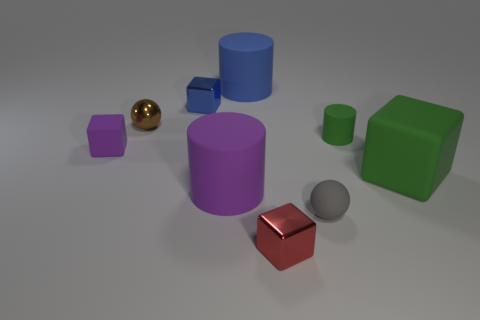Does the red object have the same material as the small sphere behind the rubber ball?
Your response must be concise. Yes. Is the number of small purple matte things behind the green cylinder greater than the number of blue rubber things?
Ensure brevity in your answer.  No. There is a rubber object that is the same color as the large matte cube; what is its shape?
Make the answer very short. Cylinder. Are there any tiny purple cubes that have the same material as the small gray ball?
Provide a succinct answer. Yes. Does the small sphere on the right side of the tiny red shiny thing have the same material as the thing behind the blue metal thing?
Give a very brief answer. Yes. Are there an equal number of spheres that are in front of the matte ball and small metallic blocks that are behind the small cylinder?
Your answer should be very brief. No. There is a cylinder that is the same size as the purple matte block; what color is it?
Keep it short and to the point. Green. Are there any big blocks of the same color as the tiny cylinder?
Your answer should be very brief. Yes. How many objects are matte cylinders to the left of the gray ball or large green cubes?
Give a very brief answer. 3. What number of other objects are there of the same size as the green matte block?
Offer a terse response. 2. 